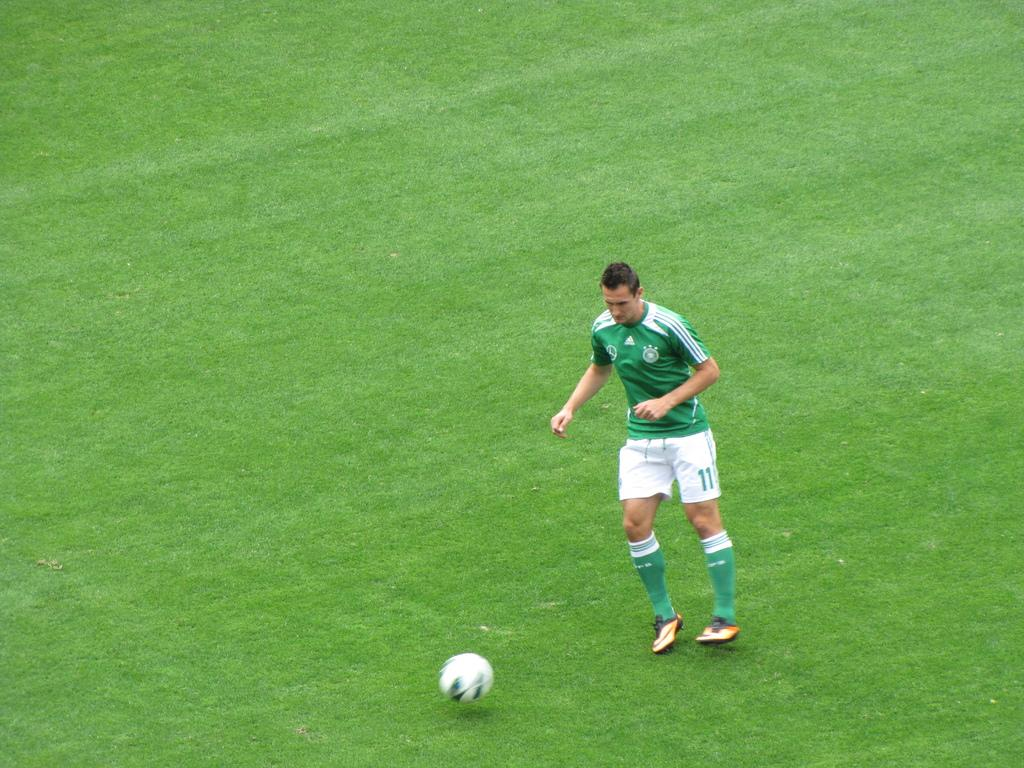<image>
Share a concise interpretation of the image provided. Soccer player #11 runs with the ball on the pitch. 